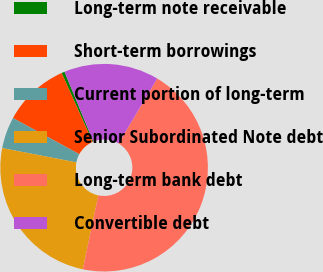<chart> <loc_0><loc_0><loc_500><loc_500><pie_chart><fcel>Long-term note receivable<fcel>Short-term borrowings<fcel>Current portion of long-term<fcel>Senior Subordinated Note debt<fcel>Long-term bank debt<fcel>Convertible debt<nl><fcel>0.48%<fcel>10.35%<fcel>4.91%<fcel>24.74%<fcel>44.73%<fcel>14.78%<nl></chart> 